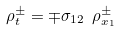<formula> <loc_0><loc_0><loc_500><loc_500>\rho ^ { \pm } _ { t } = \mp \sigma _ { 1 2 } \ \rho ^ { \pm } _ { x _ { 1 } }</formula> 